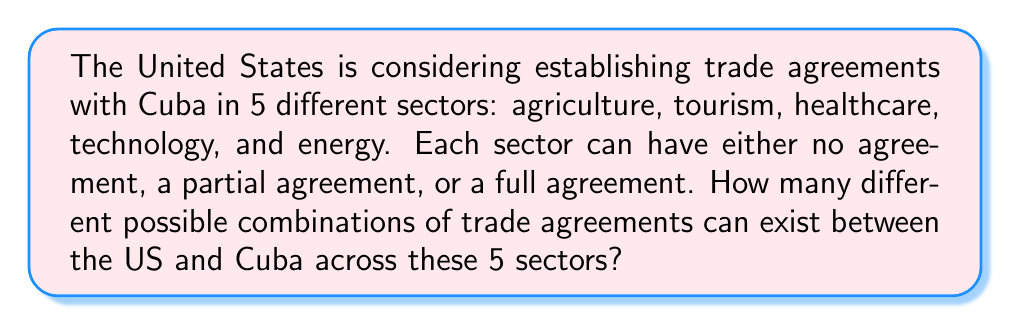What is the answer to this math problem? Let's approach this step-by-step:

1) For each sector, there are 3 possibilities:
   - No agreement
   - Partial agreement
   - Full agreement

2) This means that for each sector, we have 3 choices.

3) We need to make this choice independently for each of the 5 sectors.

4) This scenario is a perfect application of the multiplication principle in combinatorics.

5) The multiplication principle states that if we have a series of independent choices, where the first choice has $m_1$ options, the second has $m_2$ options, and so on up to the $n$-th choice with $m_n$ options, then the total number of possible outcomes is:

   $$m_1 \times m_2 \times ... \times m_n$$

6) In our case, we have 5 sectors, and each sector has 3 options. So we have:

   $$3 \times 3 \times 3 \times 3 \times 3 = 3^5$$

7) Calculate $3^5$:
   $$3^5 = 3 \times 3 \times 3 \times 3 \times 3 = 243$$

Therefore, there are 243 different possible combinations of trade agreements between the US and Cuba across these 5 sectors.
Answer: $243$ 